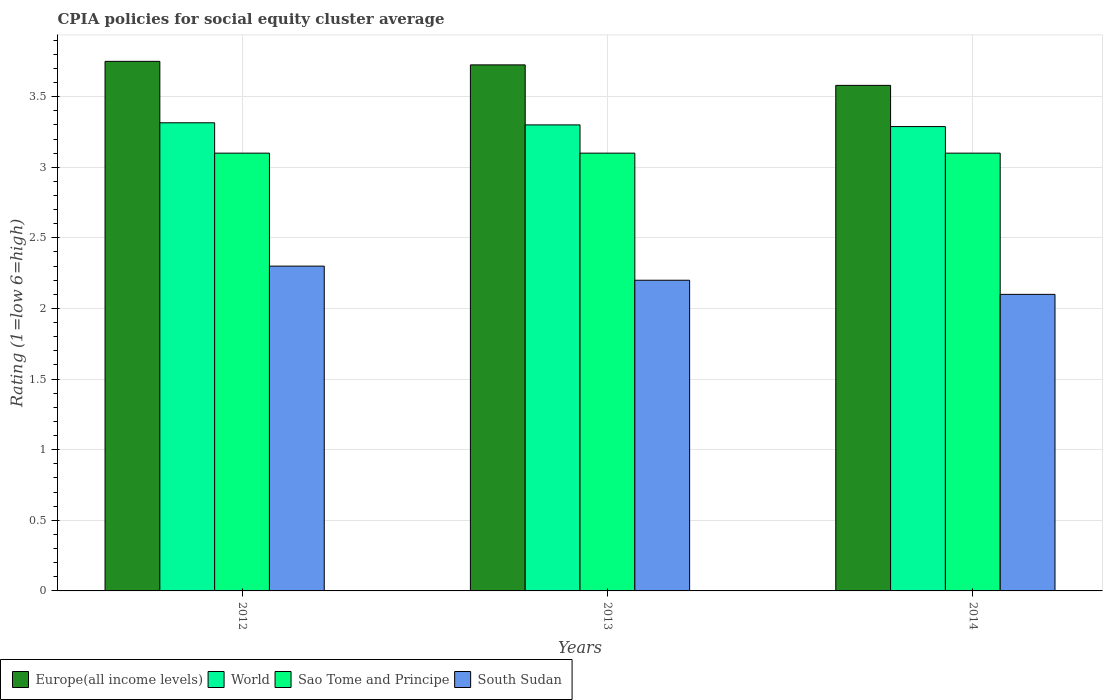How many groups of bars are there?
Your response must be concise. 3. How many bars are there on the 2nd tick from the right?
Your answer should be very brief. 4. Across all years, what is the maximum CPIA rating in World?
Provide a short and direct response. 3.31. What is the total CPIA rating in Europe(all income levels) in the graph?
Your response must be concise. 11.05. What is the difference between the CPIA rating in Sao Tome and Principe in 2012 and that in 2013?
Offer a terse response. 0. What is the difference between the CPIA rating in Europe(all income levels) in 2012 and the CPIA rating in World in 2013?
Offer a terse response. 0.45. In the year 2014, what is the difference between the CPIA rating in World and CPIA rating in South Sudan?
Provide a short and direct response. 1.19. In how many years, is the CPIA rating in Europe(all income levels) greater than 0.7?
Provide a succinct answer. 3. What is the ratio of the CPIA rating in Europe(all income levels) in 2013 to that in 2014?
Your response must be concise. 1.04. Is the CPIA rating in World in 2012 less than that in 2013?
Ensure brevity in your answer.  No. Is the difference between the CPIA rating in World in 2012 and 2014 greater than the difference between the CPIA rating in South Sudan in 2012 and 2014?
Keep it short and to the point. No. What is the difference between the highest and the second highest CPIA rating in South Sudan?
Keep it short and to the point. 0.1. What is the difference between the highest and the lowest CPIA rating in World?
Keep it short and to the point. 0.03. In how many years, is the CPIA rating in South Sudan greater than the average CPIA rating in South Sudan taken over all years?
Offer a terse response. 2. Is the sum of the CPIA rating in World in 2012 and 2013 greater than the maximum CPIA rating in South Sudan across all years?
Your answer should be compact. Yes. What does the 4th bar from the left in 2012 represents?
Provide a short and direct response. South Sudan. Is it the case that in every year, the sum of the CPIA rating in World and CPIA rating in South Sudan is greater than the CPIA rating in Europe(all income levels)?
Keep it short and to the point. Yes. Are all the bars in the graph horizontal?
Offer a very short reply. No. How many years are there in the graph?
Provide a short and direct response. 3. What is the difference between two consecutive major ticks on the Y-axis?
Your answer should be very brief. 0.5. Are the values on the major ticks of Y-axis written in scientific E-notation?
Keep it short and to the point. No. Does the graph contain grids?
Offer a very short reply. Yes. Where does the legend appear in the graph?
Provide a short and direct response. Bottom left. What is the title of the graph?
Offer a terse response. CPIA policies for social equity cluster average. What is the label or title of the X-axis?
Your response must be concise. Years. What is the label or title of the Y-axis?
Offer a terse response. Rating (1=low 6=high). What is the Rating (1=low 6=high) in Europe(all income levels) in 2012?
Your answer should be compact. 3.75. What is the Rating (1=low 6=high) of World in 2012?
Offer a very short reply. 3.31. What is the Rating (1=low 6=high) in South Sudan in 2012?
Ensure brevity in your answer.  2.3. What is the Rating (1=low 6=high) in Europe(all income levels) in 2013?
Your answer should be compact. 3.73. What is the Rating (1=low 6=high) in Europe(all income levels) in 2014?
Offer a very short reply. 3.58. What is the Rating (1=low 6=high) in World in 2014?
Offer a very short reply. 3.29. What is the Rating (1=low 6=high) of Sao Tome and Principe in 2014?
Your answer should be compact. 3.1. Across all years, what is the maximum Rating (1=low 6=high) of Europe(all income levels)?
Give a very brief answer. 3.75. Across all years, what is the maximum Rating (1=low 6=high) of World?
Make the answer very short. 3.31. Across all years, what is the maximum Rating (1=low 6=high) of Sao Tome and Principe?
Give a very brief answer. 3.1. Across all years, what is the minimum Rating (1=low 6=high) in Europe(all income levels)?
Give a very brief answer. 3.58. Across all years, what is the minimum Rating (1=low 6=high) in World?
Offer a very short reply. 3.29. Across all years, what is the minimum Rating (1=low 6=high) of South Sudan?
Offer a terse response. 2.1. What is the total Rating (1=low 6=high) in Europe(all income levels) in the graph?
Your answer should be very brief. 11.05. What is the total Rating (1=low 6=high) in World in the graph?
Keep it short and to the point. 9.9. What is the total Rating (1=low 6=high) of Sao Tome and Principe in the graph?
Provide a succinct answer. 9.3. What is the difference between the Rating (1=low 6=high) in Europe(all income levels) in 2012 and that in 2013?
Give a very brief answer. 0.03. What is the difference between the Rating (1=low 6=high) in World in 2012 and that in 2013?
Keep it short and to the point. 0.01. What is the difference between the Rating (1=low 6=high) of Sao Tome and Principe in 2012 and that in 2013?
Keep it short and to the point. 0. What is the difference between the Rating (1=low 6=high) of Europe(all income levels) in 2012 and that in 2014?
Offer a terse response. 0.17. What is the difference between the Rating (1=low 6=high) of World in 2012 and that in 2014?
Your answer should be very brief. 0.03. What is the difference between the Rating (1=low 6=high) of South Sudan in 2012 and that in 2014?
Make the answer very short. 0.2. What is the difference between the Rating (1=low 6=high) of Europe(all income levels) in 2013 and that in 2014?
Your response must be concise. 0.14. What is the difference between the Rating (1=low 6=high) in World in 2013 and that in 2014?
Offer a very short reply. 0.01. What is the difference between the Rating (1=low 6=high) of Sao Tome and Principe in 2013 and that in 2014?
Provide a short and direct response. 0. What is the difference between the Rating (1=low 6=high) of Europe(all income levels) in 2012 and the Rating (1=low 6=high) of World in 2013?
Offer a very short reply. 0.45. What is the difference between the Rating (1=low 6=high) in Europe(all income levels) in 2012 and the Rating (1=low 6=high) in Sao Tome and Principe in 2013?
Provide a succinct answer. 0.65. What is the difference between the Rating (1=low 6=high) in Europe(all income levels) in 2012 and the Rating (1=low 6=high) in South Sudan in 2013?
Your answer should be compact. 1.55. What is the difference between the Rating (1=low 6=high) of World in 2012 and the Rating (1=low 6=high) of Sao Tome and Principe in 2013?
Provide a succinct answer. 0.21. What is the difference between the Rating (1=low 6=high) of World in 2012 and the Rating (1=low 6=high) of South Sudan in 2013?
Make the answer very short. 1.11. What is the difference between the Rating (1=low 6=high) in Sao Tome and Principe in 2012 and the Rating (1=low 6=high) in South Sudan in 2013?
Your answer should be compact. 0.9. What is the difference between the Rating (1=low 6=high) of Europe(all income levels) in 2012 and the Rating (1=low 6=high) of World in 2014?
Make the answer very short. 0.46. What is the difference between the Rating (1=low 6=high) of Europe(all income levels) in 2012 and the Rating (1=low 6=high) of Sao Tome and Principe in 2014?
Your answer should be compact. 0.65. What is the difference between the Rating (1=low 6=high) in Europe(all income levels) in 2012 and the Rating (1=low 6=high) in South Sudan in 2014?
Offer a terse response. 1.65. What is the difference between the Rating (1=low 6=high) in World in 2012 and the Rating (1=low 6=high) in Sao Tome and Principe in 2014?
Provide a succinct answer. 0.21. What is the difference between the Rating (1=low 6=high) in World in 2012 and the Rating (1=low 6=high) in South Sudan in 2014?
Your answer should be very brief. 1.22. What is the difference between the Rating (1=low 6=high) in Sao Tome and Principe in 2012 and the Rating (1=low 6=high) in South Sudan in 2014?
Provide a succinct answer. 1. What is the difference between the Rating (1=low 6=high) of Europe(all income levels) in 2013 and the Rating (1=low 6=high) of World in 2014?
Offer a terse response. 0.44. What is the difference between the Rating (1=low 6=high) in Europe(all income levels) in 2013 and the Rating (1=low 6=high) in Sao Tome and Principe in 2014?
Your answer should be very brief. 0.62. What is the difference between the Rating (1=low 6=high) of Europe(all income levels) in 2013 and the Rating (1=low 6=high) of South Sudan in 2014?
Your answer should be very brief. 1.62. What is the difference between the Rating (1=low 6=high) in World in 2013 and the Rating (1=low 6=high) in South Sudan in 2014?
Provide a succinct answer. 1.2. What is the average Rating (1=low 6=high) in Europe(all income levels) per year?
Your answer should be very brief. 3.69. What is the average Rating (1=low 6=high) of World per year?
Offer a very short reply. 3.3. What is the average Rating (1=low 6=high) of South Sudan per year?
Offer a very short reply. 2.2. In the year 2012, what is the difference between the Rating (1=low 6=high) of Europe(all income levels) and Rating (1=low 6=high) of World?
Offer a terse response. 0.43. In the year 2012, what is the difference between the Rating (1=low 6=high) in Europe(all income levels) and Rating (1=low 6=high) in Sao Tome and Principe?
Provide a succinct answer. 0.65. In the year 2012, what is the difference between the Rating (1=low 6=high) of Europe(all income levels) and Rating (1=low 6=high) of South Sudan?
Offer a very short reply. 1.45. In the year 2012, what is the difference between the Rating (1=low 6=high) of World and Rating (1=low 6=high) of Sao Tome and Principe?
Ensure brevity in your answer.  0.21. In the year 2013, what is the difference between the Rating (1=low 6=high) of Europe(all income levels) and Rating (1=low 6=high) of World?
Your answer should be compact. 0.42. In the year 2013, what is the difference between the Rating (1=low 6=high) of Europe(all income levels) and Rating (1=low 6=high) of Sao Tome and Principe?
Keep it short and to the point. 0.62. In the year 2013, what is the difference between the Rating (1=low 6=high) in Europe(all income levels) and Rating (1=low 6=high) in South Sudan?
Provide a succinct answer. 1.52. In the year 2013, what is the difference between the Rating (1=low 6=high) of World and Rating (1=low 6=high) of South Sudan?
Your answer should be very brief. 1.1. In the year 2014, what is the difference between the Rating (1=low 6=high) in Europe(all income levels) and Rating (1=low 6=high) in World?
Your answer should be compact. 0.29. In the year 2014, what is the difference between the Rating (1=low 6=high) of Europe(all income levels) and Rating (1=low 6=high) of Sao Tome and Principe?
Your response must be concise. 0.48. In the year 2014, what is the difference between the Rating (1=low 6=high) of Europe(all income levels) and Rating (1=low 6=high) of South Sudan?
Your answer should be very brief. 1.48. In the year 2014, what is the difference between the Rating (1=low 6=high) in World and Rating (1=low 6=high) in Sao Tome and Principe?
Provide a short and direct response. 0.19. In the year 2014, what is the difference between the Rating (1=low 6=high) of World and Rating (1=low 6=high) of South Sudan?
Ensure brevity in your answer.  1.19. In the year 2014, what is the difference between the Rating (1=low 6=high) in Sao Tome and Principe and Rating (1=low 6=high) in South Sudan?
Keep it short and to the point. 1. What is the ratio of the Rating (1=low 6=high) in World in 2012 to that in 2013?
Give a very brief answer. 1. What is the ratio of the Rating (1=low 6=high) of South Sudan in 2012 to that in 2013?
Your answer should be compact. 1.05. What is the ratio of the Rating (1=low 6=high) in Europe(all income levels) in 2012 to that in 2014?
Your answer should be compact. 1.05. What is the ratio of the Rating (1=low 6=high) of World in 2012 to that in 2014?
Your answer should be very brief. 1.01. What is the ratio of the Rating (1=low 6=high) in Sao Tome and Principe in 2012 to that in 2014?
Offer a very short reply. 1. What is the ratio of the Rating (1=low 6=high) in South Sudan in 2012 to that in 2014?
Ensure brevity in your answer.  1.1. What is the ratio of the Rating (1=low 6=high) of Europe(all income levels) in 2013 to that in 2014?
Offer a terse response. 1.04. What is the ratio of the Rating (1=low 6=high) of Sao Tome and Principe in 2013 to that in 2014?
Offer a terse response. 1. What is the ratio of the Rating (1=low 6=high) in South Sudan in 2013 to that in 2014?
Ensure brevity in your answer.  1.05. What is the difference between the highest and the second highest Rating (1=low 6=high) in Europe(all income levels)?
Your response must be concise. 0.03. What is the difference between the highest and the second highest Rating (1=low 6=high) in World?
Make the answer very short. 0.01. What is the difference between the highest and the lowest Rating (1=low 6=high) of Europe(all income levels)?
Provide a succinct answer. 0.17. What is the difference between the highest and the lowest Rating (1=low 6=high) in World?
Give a very brief answer. 0.03. What is the difference between the highest and the lowest Rating (1=low 6=high) in Sao Tome and Principe?
Ensure brevity in your answer.  0. What is the difference between the highest and the lowest Rating (1=low 6=high) in South Sudan?
Your answer should be very brief. 0.2. 